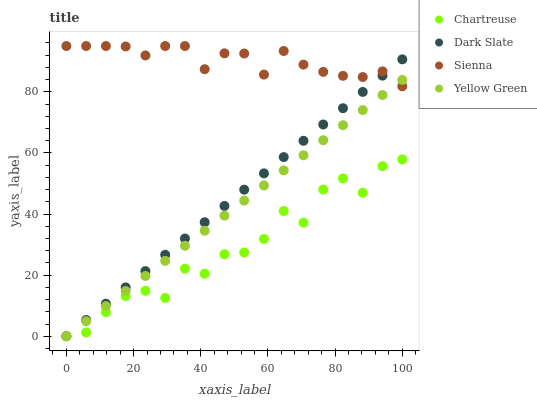Does Chartreuse have the minimum area under the curve?
Answer yes or no. Yes. Does Sienna have the maximum area under the curve?
Answer yes or no. Yes. Does Dark Slate have the minimum area under the curve?
Answer yes or no. No. Does Dark Slate have the maximum area under the curve?
Answer yes or no. No. Is Dark Slate the smoothest?
Answer yes or no. Yes. Is Chartreuse the roughest?
Answer yes or no. Yes. Is Chartreuse the smoothest?
Answer yes or no. No. Is Dark Slate the roughest?
Answer yes or no. No. Does Dark Slate have the lowest value?
Answer yes or no. Yes. Does Sienna have the highest value?
Answer yes or no. Yes. Does Dark Slate have the highest value?
Answer yes or no. No. Is Chartreuse less than Sienna?
Answer yes or no. Yes. Is Sienna greater than Chartreuse?
Answer yes or no. Yes. Does Sienna intersect Dark Slate?
Answer yes or no. Yes. Is Sienna less than Dark Slate?
Answer yes or no. No. Is Sienna greater than Dark Slate?
Answer yes or no. No. Does Chartreuse intersect Sienna?
Answer yes or no. No. 